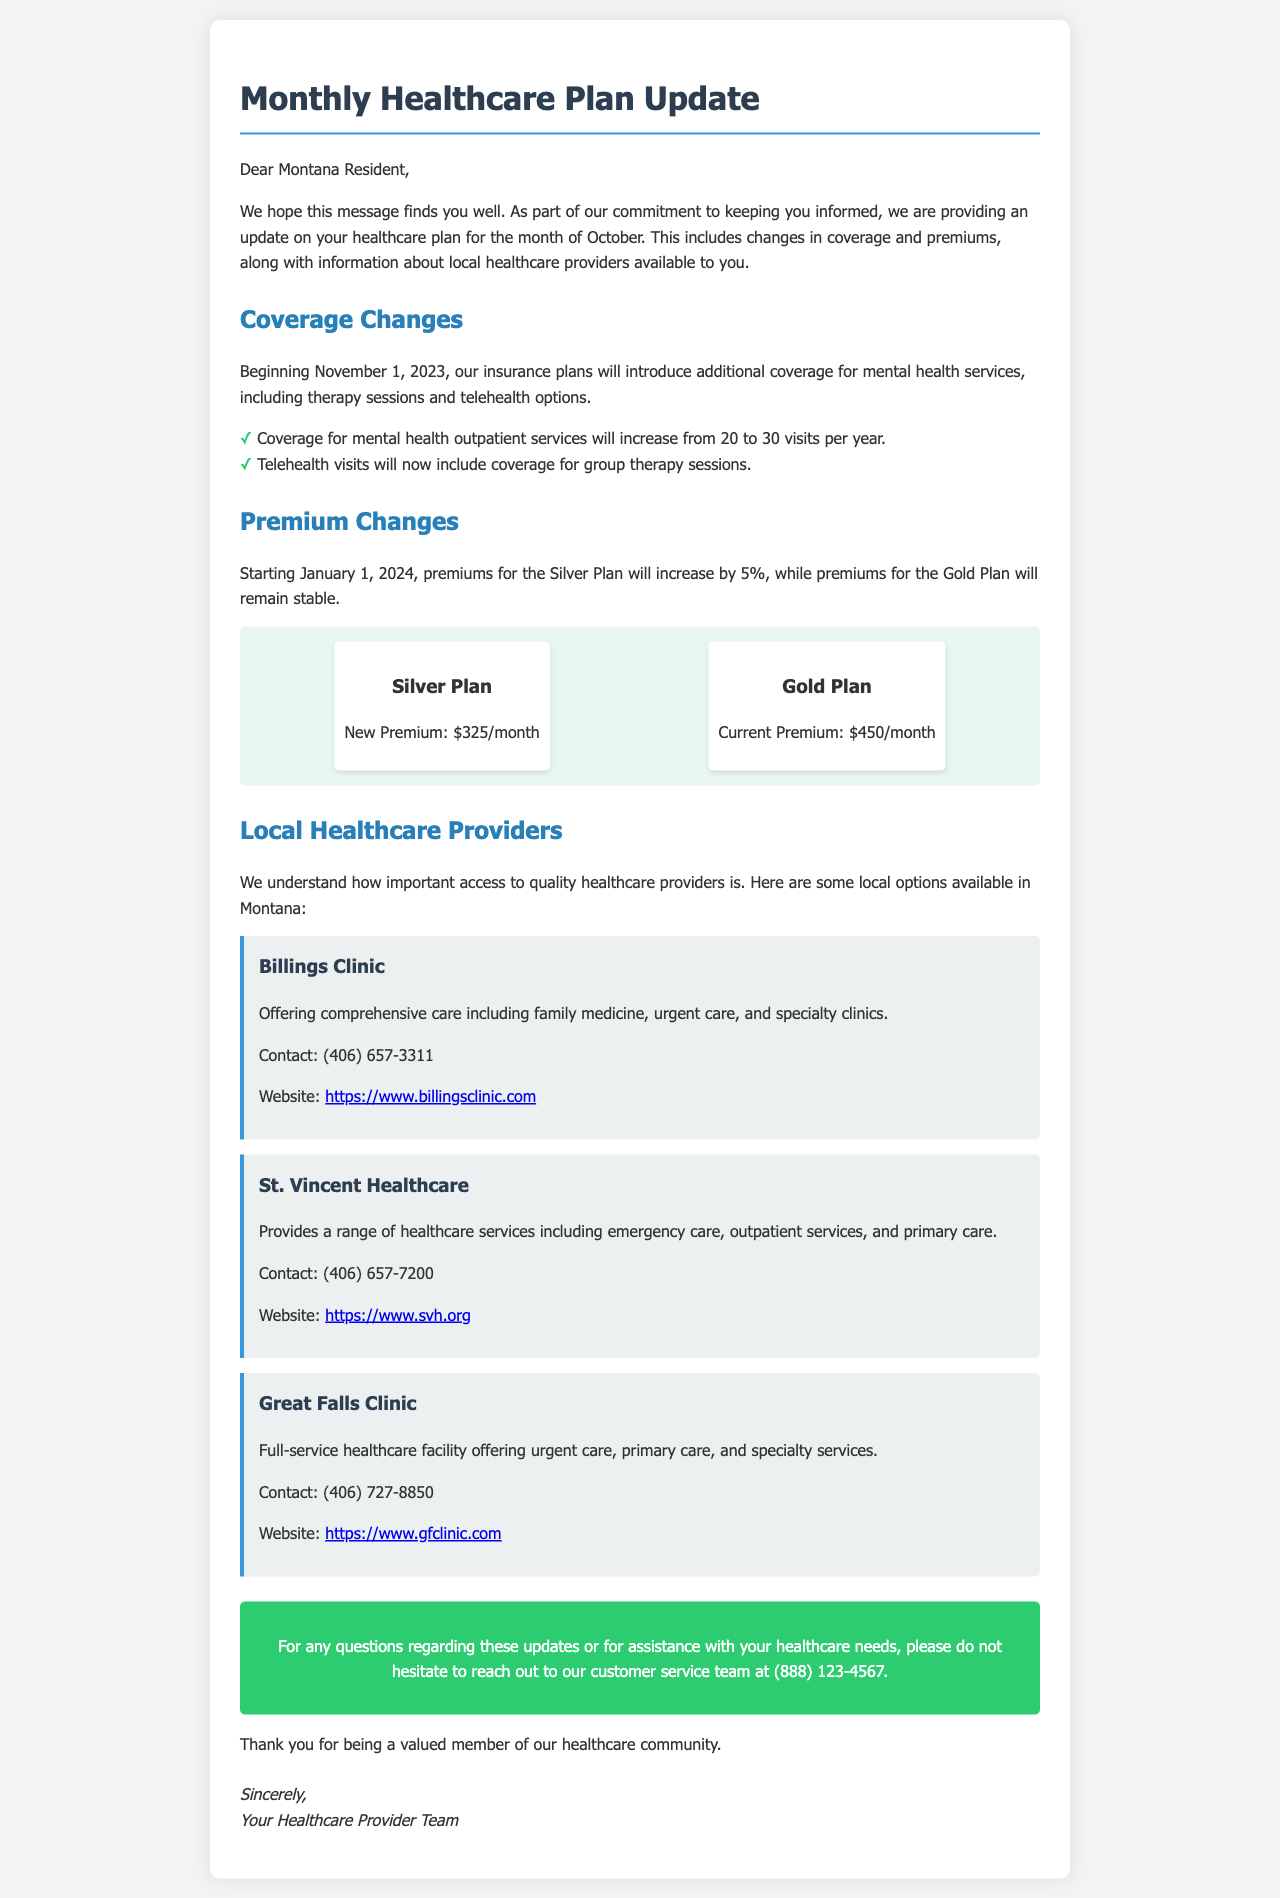What is the new premium for the Silver Plan? The new premium for the Silver Plan is outlined under the Premium Changes section, which states it will be $325/month.
Answer: $325/month How many mental health outpatient visits are covered per year? The document specifies that coverage for mental health outpatient services will increase to 30 visits per year.
Answer: 30 visits What is the start date for the new mental health coverage? The document mentions that the new mental health coverage begins on November 1, 2023, as indicated in the Coverage Changes section.
Answer: November 1, 2023 Which plan's premium will remain stable? The document states that the premiums for the Gold Plan will remain stable, whereas the Silver Plan's premium will increase.
Answer: Gold Plan What type of therapy will now be covered under telehealth? The document specifies that telehealth visits will now include coverage for group therapy sessions.
Answer: Group therapy sessions What service does Billings Clinic offer? The document lists that Billings Clinic offers comprehensive care including family medicine, urgent care, and specialty clinics.
Answer: Family medicine Who can be contacted at (406) 657-7200? The document states that St. Vincent Healthcare can be contacted at that number, which offers emergency care, outpatient services, and primary care.
Answer: St. Vincent Healthcare When do the premium changes take effect? The document specifies that premium changes for the Silver Plan will take effect starting January 1, 2024.
Answer: January 1, 2024 How is the information organized in this document? The organization is structured with sections for coverage changes, premium changes, and local healthcare providers, highlighting different aspects in clear subheaders.
Answer: Sections for coverage changes, premium changes, and local healthcare providers 